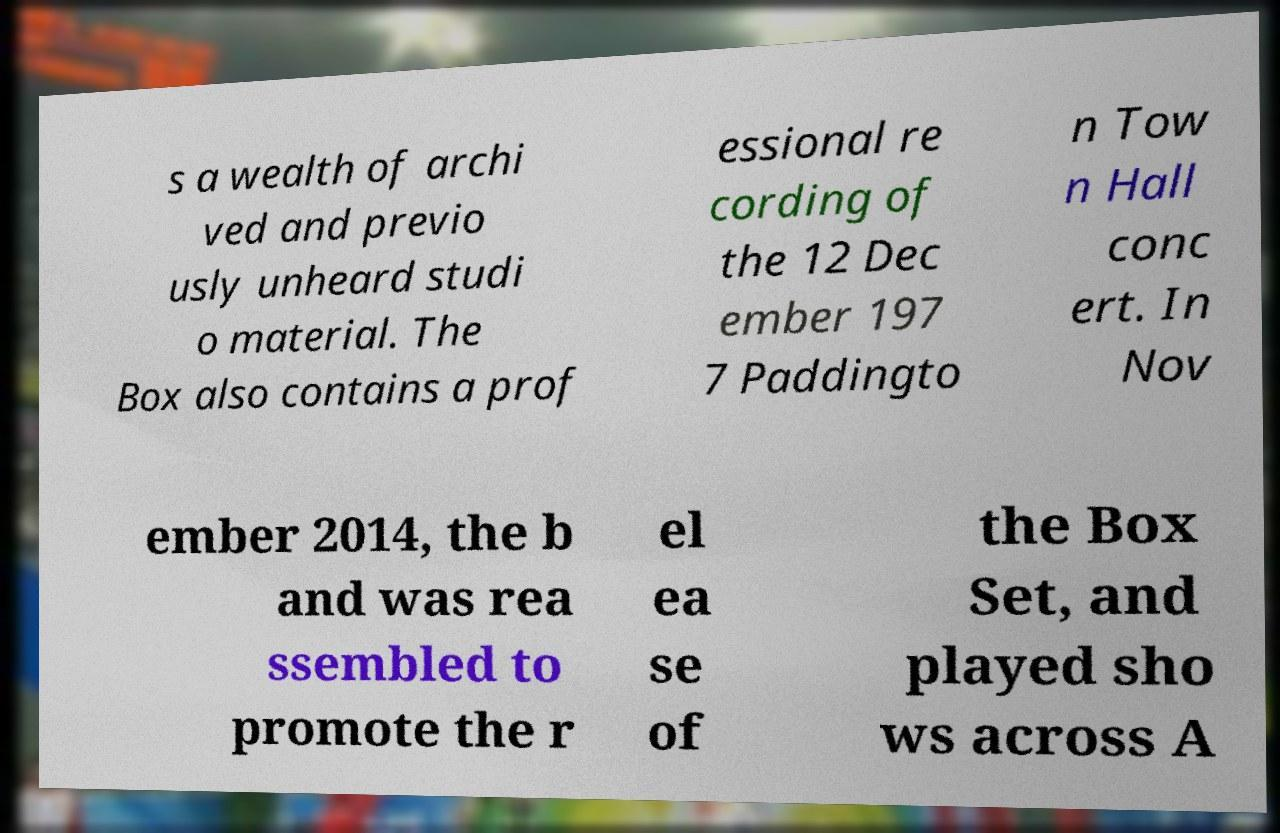For documentation purposes, I need the text within this image transcribed. Could you provide that? s a wealth of archi ved and previo usly unheard studi o material. The Box also contains a prof essional re cording of the 12 Dec ember 197 7 Paddingto n Tow n Hall conc ert. In Nov ember 2014, the b and was rea ssembled to promote the r el ea se of the Box Set, and played sho ws across A 